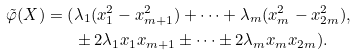<formula> <loc_0><loc_0><loc_500><loc_500>\tilde { \varphi } ( X ) = ( & \lambda _ { 1 } ( x _ { 1 } ^ { 2 } - x _ { m + 1 } ^ { 2 } ) + \dots + \lambda _ { m } ( x _ { m } ^ { 2 } - x _ { 2 m } ^ { 2 } ) , \, \\ & \pm 2 \lambda _ { 1 } x _ { 1 } x _ { m + 1 } \pm \dots \pm 2 \lambda _ { m } x _ { m } x _ { 2 m } ) .</formula> 